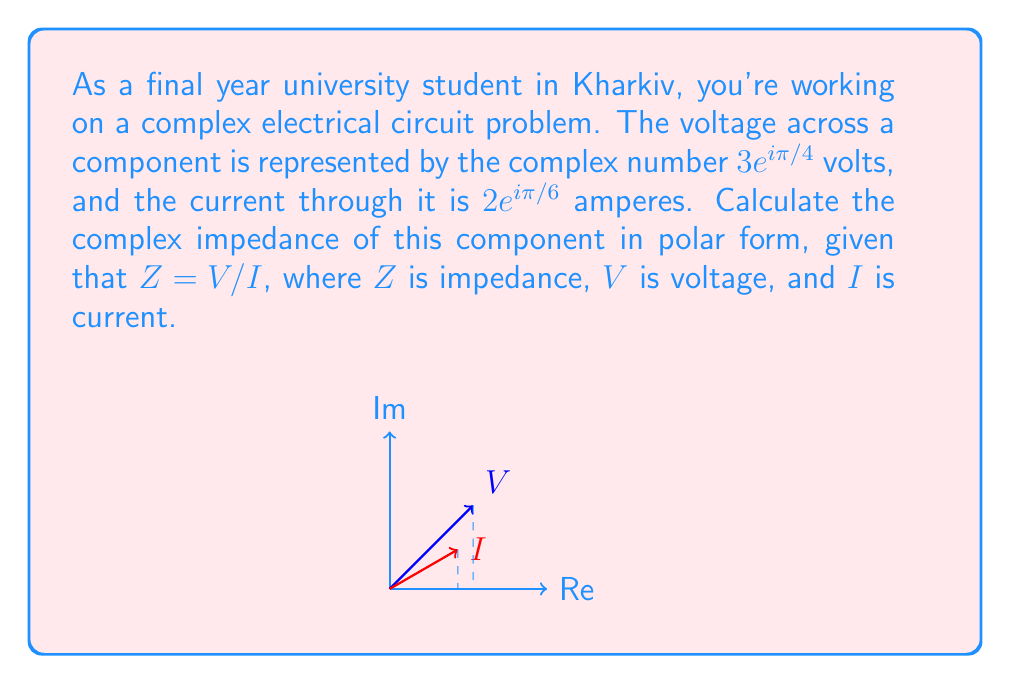Provide a solution to this math problem. Let's solve this step-by-step:

1) We are given:
   Voltage $V = 3e^{i\pi/4}$ volts
   Current $I = 2e^{i\pi/6}$ amperes

2) The formula for impedance is $Z = V/I$

3) In polar form, when dividing complex numbers, we divide the magnitudes and subtract the angles:

   $$Z = \frac{3e^{i\pi/4}}{2e^{i\pi/6}} = \frac{3}{2}e^{i(\pi/4 - \pi/6)}$$

4) Simplify the fraction of magnitudes:
   $$\frac{3}{2} = 1.5$$

5) Simplify the difference of angles:
   $$\pi/4 - \pi/6 = 3\pi/12 - 2\pi/12 = \pi/12$$

6) Therefore, the impedance in polar form is:

   $$Z = 1.5e^{i\pi/12}$$

This represents a magnitude of 1.5 ohms and an angle of $\pi/12$ radians or 15 degrees.
Answer: $1.5e^{i\pi/12}$ ohms 